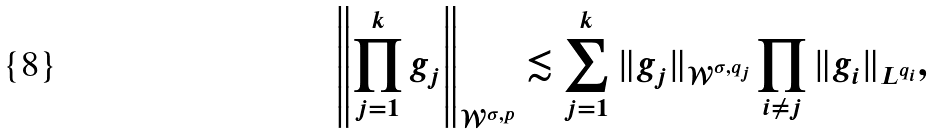Convert formula to latex. <formula><loc_0><loc_0><loc_500><loc_500>\left \| \prod _ { j = 1 } ^ { k } g _ { j } \right \| _ { \mathcal { W } ^ { \sigma , p } } \lesssim \sum _ { j = 1 } ^ { k } \| g _ { j } \| _ { \mathcal { W } ^ { \sigma , q _ { j } } } \prod _ { i \neq j } \| g _ { i } \| _ { L ^ { q _ { i } } } ,</formula> 